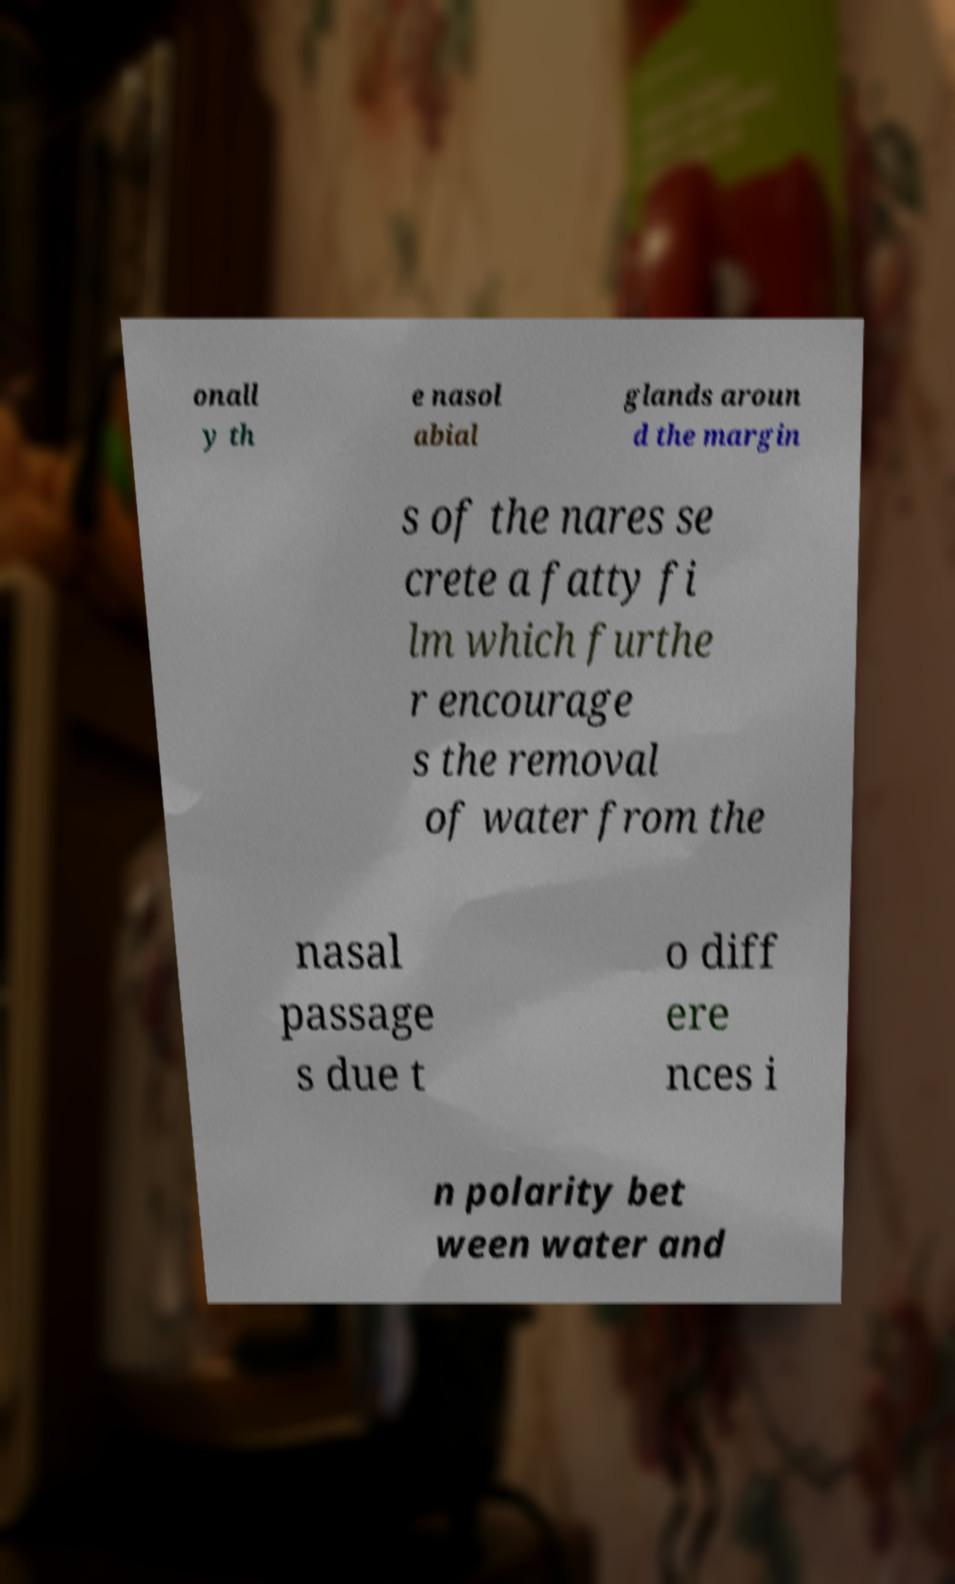What messages or text are displayed in this image? I need them in a readable, typed format. onall y th e nasol abial glands aroun d the margin s of the nares se crete a fatty fi lm which furthe r encourage s the removal of water from the nasal passage s due t o diff ere nces i n polarity bet ween water and 